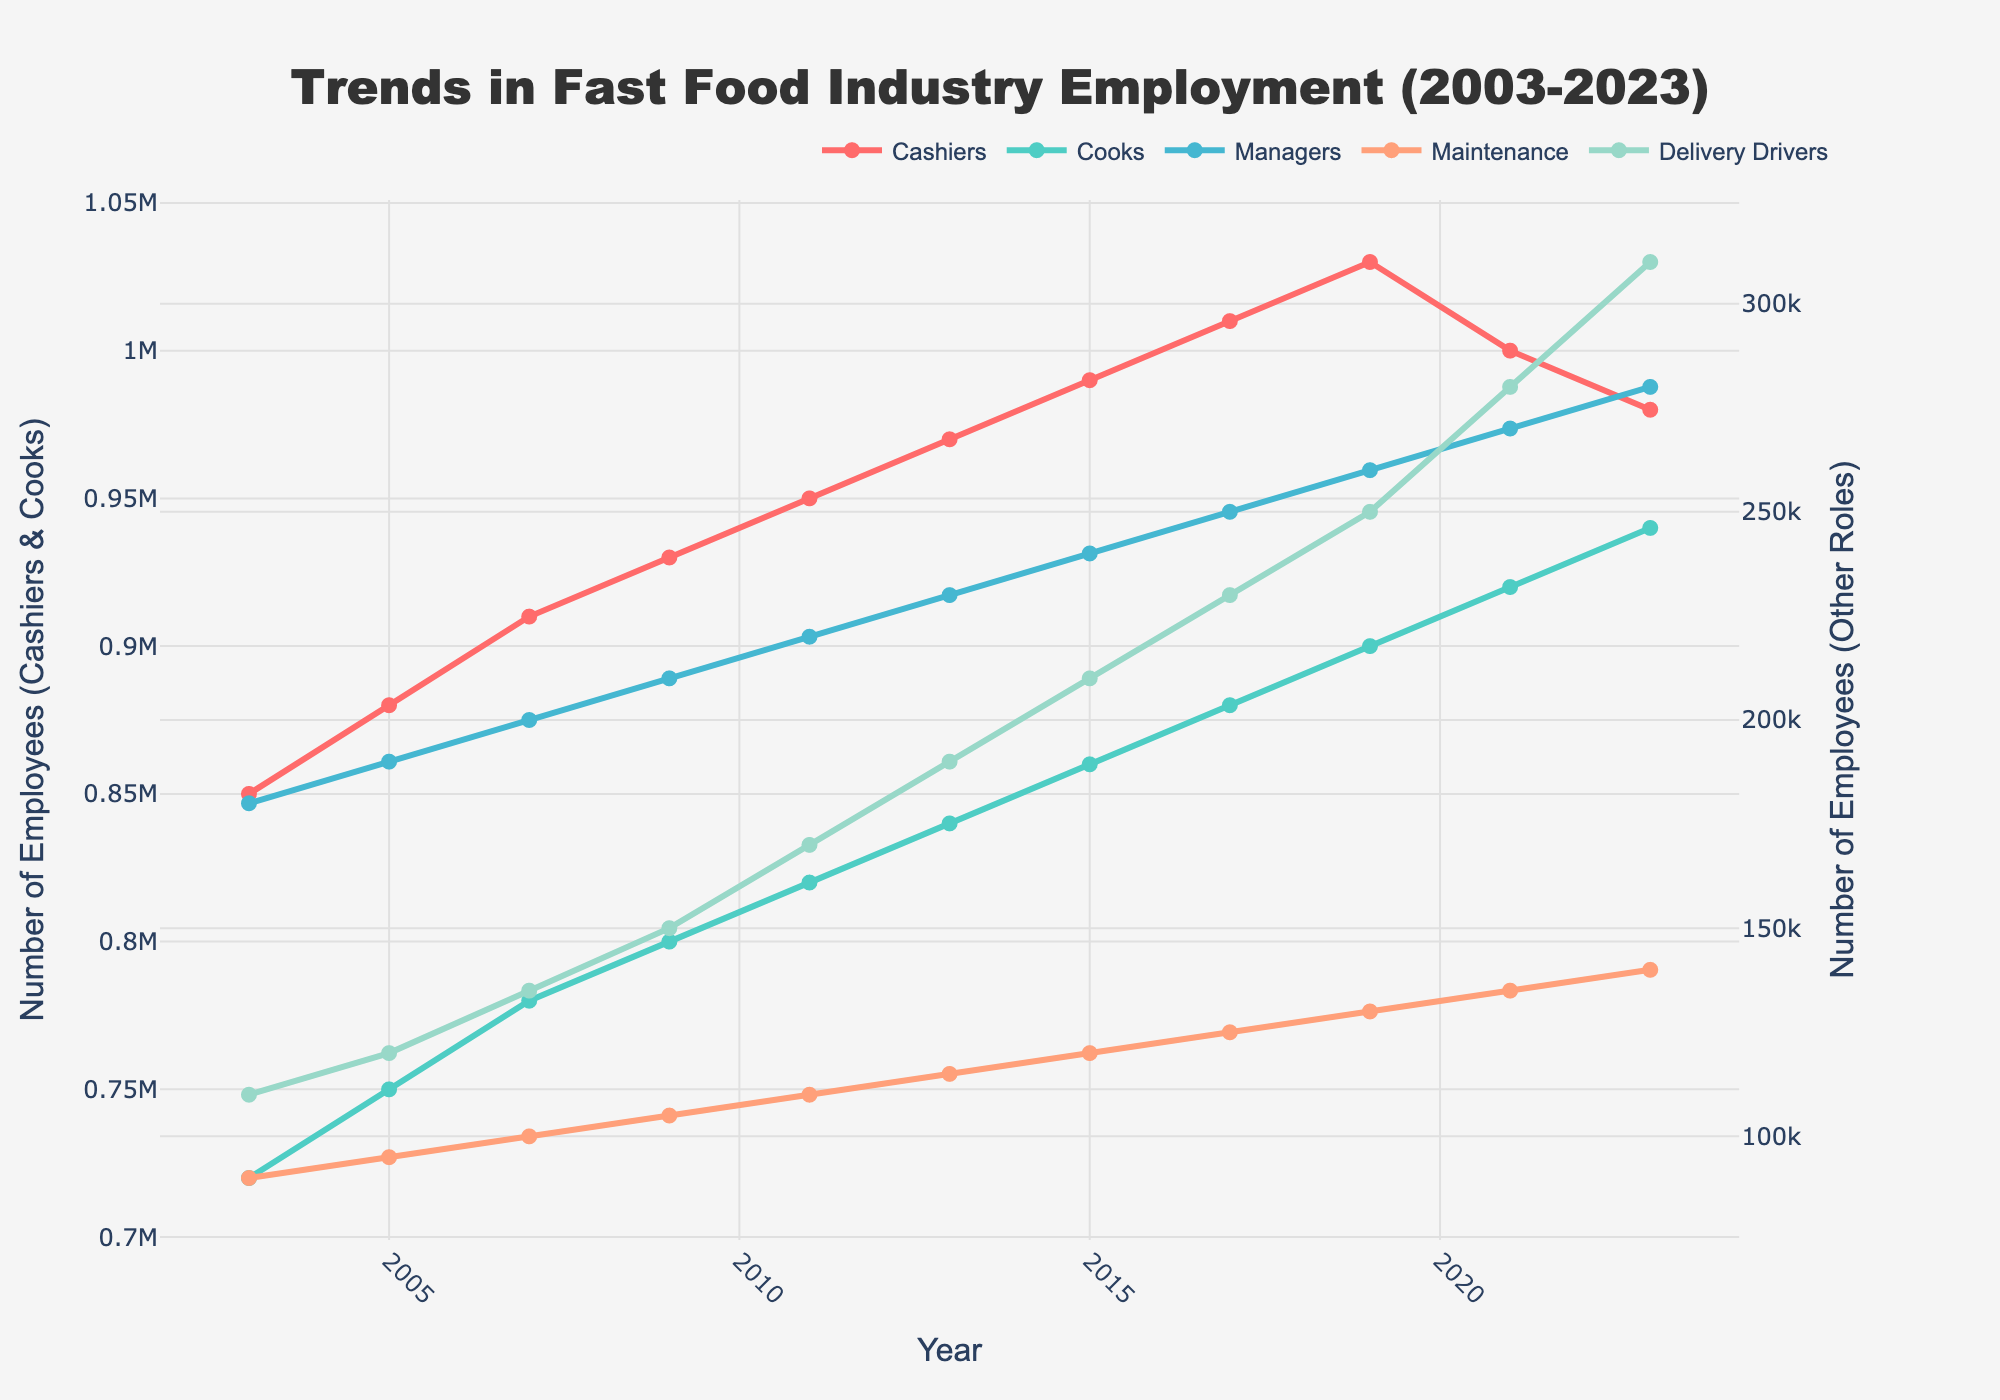What year did Managers reach the 250,000 employment mark? Check the plot and follow the Managers' line to see when it reaches 250,000. Manager roles reach 250,000 in 2017.
Answer: 2017 Which job role saw the most significant increase in employment from 2003 to 2023? Compare the initial and final values of each job role. Delivery Drivers increased from 110,000 to 310,000, the highest jump (200,000).
Answer: Delivery Drivers Among Cashiers and Cooks, which role has a higher number of employees in 2023? Check the lines for Cashiers and Cooks in 2023. Cooks have 940,000 while Cashiers have 980,000.
Answer: Cashiers In which year did Maintenance roles surpass 100,000 employees? Trace the Maintenance line upward to see when it crosses the 100,000 mark. It surpasses in 2007.
Answer: 2007 How many more employees were Delivery Drivers than Maintenance in 2023? Find the values for both roles in 2023. Delivery Drivers: 310,000, Maintenance: 140,000. The difference is 310,000 - 140,000 = 170,000.
Answer: 170,000 What is the average number of employees for Cooks from 2003 to 2023? Add all employee numbers for Cooks between 2003-2023 and divide by the number of data points. (720,000 + 750,000 + 780,000 + 800,000 + 820,000 + 840,000 + 860,000 + 880,000 + 900,000 + 920,000 + 940,000) / 11 ≈ 827,091
Answer: ~827,091 Which role has the second-highest number of employees in 2023? Compare the final values of all roles. Delivery Drivers are the highest. Cooks have 940,000 which is the second highest.
Answer: Cooks Did the number of employees in the role of Cashiers always increase every year? Check the trend for Cashiers year by year. It increases until 2021, then decreases in 2023.
Answer: No By how much did the number of Maintenance employees change from 2005 to 2015? Find the values for 2005 and 2015, then compute the difference. 120,000 - 95,000 = 25,000.
Answer: 25,000 What color is used to represent Cooks in the plot? Refer to the color legend or line colors on the plot. Cooks are represented in green.
Answer: Green 